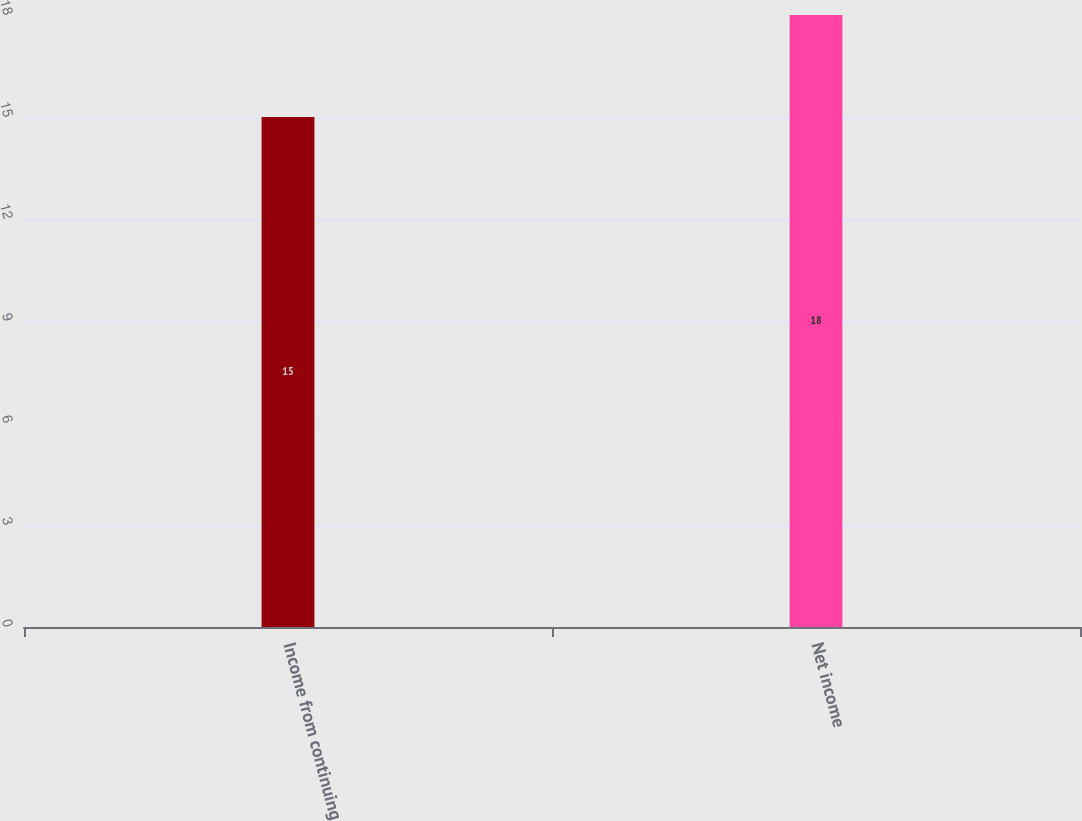<chart> <loc_0><loc_0><loc_500><loc_500><bar_chart><fcel>Income from continuing<fcel>Net income<nl><fcel>15<fcel>18<nl></chart> 